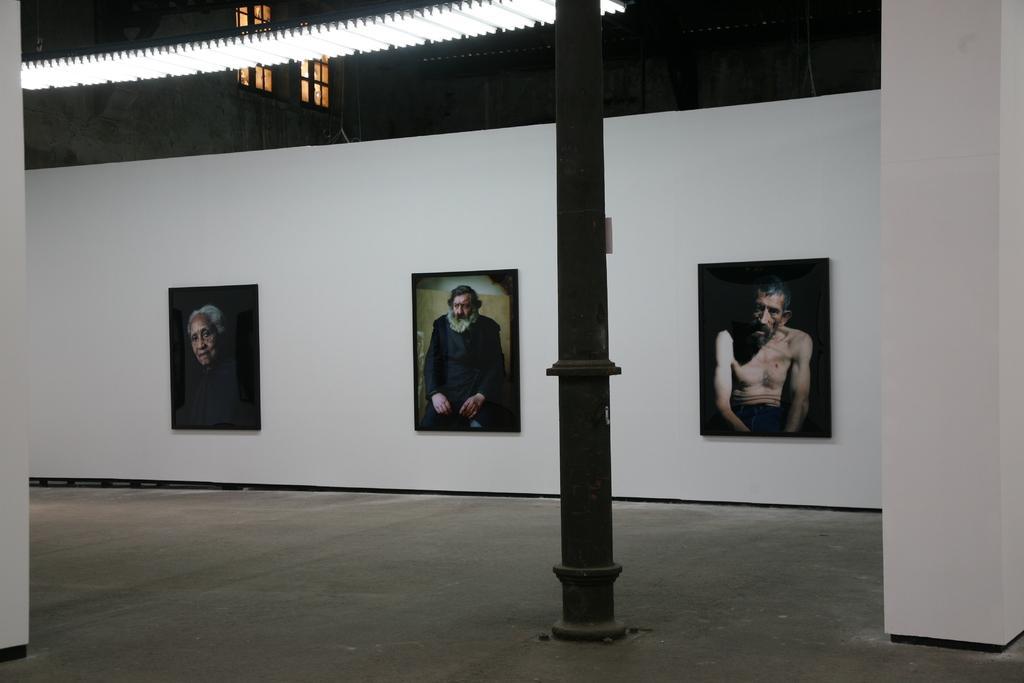Can you describe this image briefly? In this image we can see photo frames on the wall. At the top of the image there are lights, windows and other objects. On the left and the right side of the image there are pillars. At the bottom of the image there is the floor and a pole. 